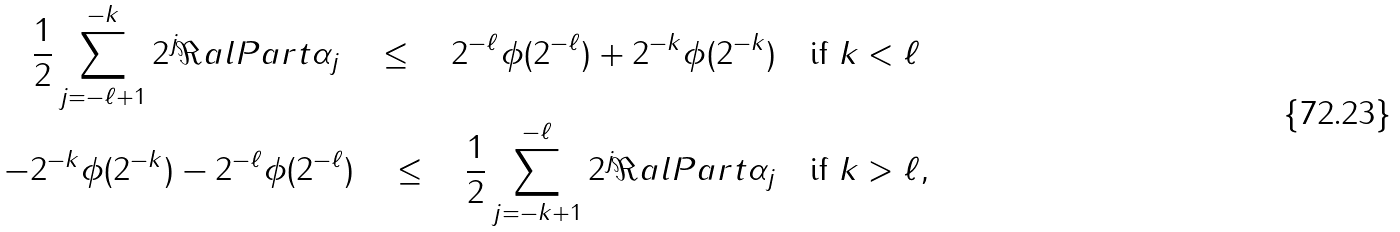<formula> <loc_0><loc_0><loc_500><loc_500>\frac { 1 } { 2 } \sum _ { j = - \ell + 1 } ^ { - k } 2 ^ { j } \Re a l P a r t \alpha _ { j } \quad \leq \quad 2 ^ { - \ell } \phi ( 2 ^ { - \ell } ) + 2 ^ { - k } \phi ( 2 ^ { - k } ) & \quad \text {if } k < \ell \\ - 2 ^ { - k } \phi ( 2 ^ { - k } ) - 2 ^ { - \ell } \phi ( 2 ^ { - \ell } ) \quad \leq \quad \frac { 1 } { 2 } \sum _ { j = - k + 1 } ^ { - \ell } 2 ^ { j } \Re a l P a r t \alpha _ { j } & \quad \text {if } k > \ell ,</formula> 